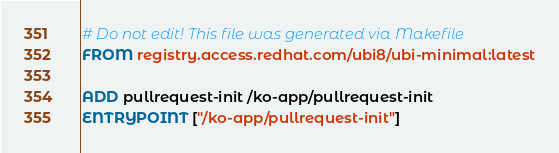Convert code to text. <code><loc_0><loc_0><loc_500><loc_500><_Dockerfile_># Do not edit! This file was generated via Makefile
FROM registry.access.redhat.com/ubi8/ubi-minimal:latest

ADD pullrequest-init /ko-app/pullrequest-init
ENTRYPOINT ["/ko-app/pullrequest-init"]
</code> 